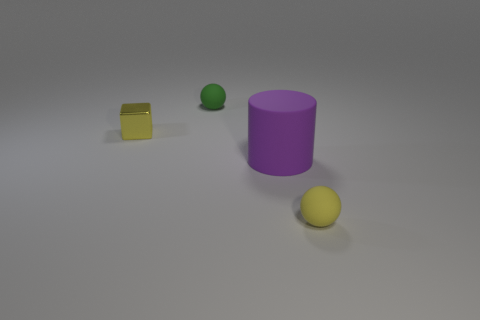Add 3 small brown metallic cylinders. How many objects exist? 7 Subtract all cylinders. How many objects are left? 3 Subtract all blocks. Subtract all rubber spheres. How many objects are left? 1 Add 3 large objects. How many large objects are left? 4 Add 4 tiny yellow matte things. How many tiny yellow matte things exist? 5 Subtract 0 green cubes. How many objects are left? 4 